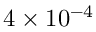<formula> <loc_0><loc_0><loc_500><loc_500>4 \times 1 0 ^ { - 4 }</formula> 